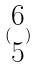<formula> <loc_0><loc_0><loc_500><loc_500>( \begin{matrix} 6 \\ 5 \end{matrix} )</formula> 